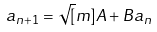<formula> <loc_0><loc_0><loc_500><loc_500>a _ { n + 1 } = \sqrt { [ } m ] { A + B a _ { n } }</formula> 